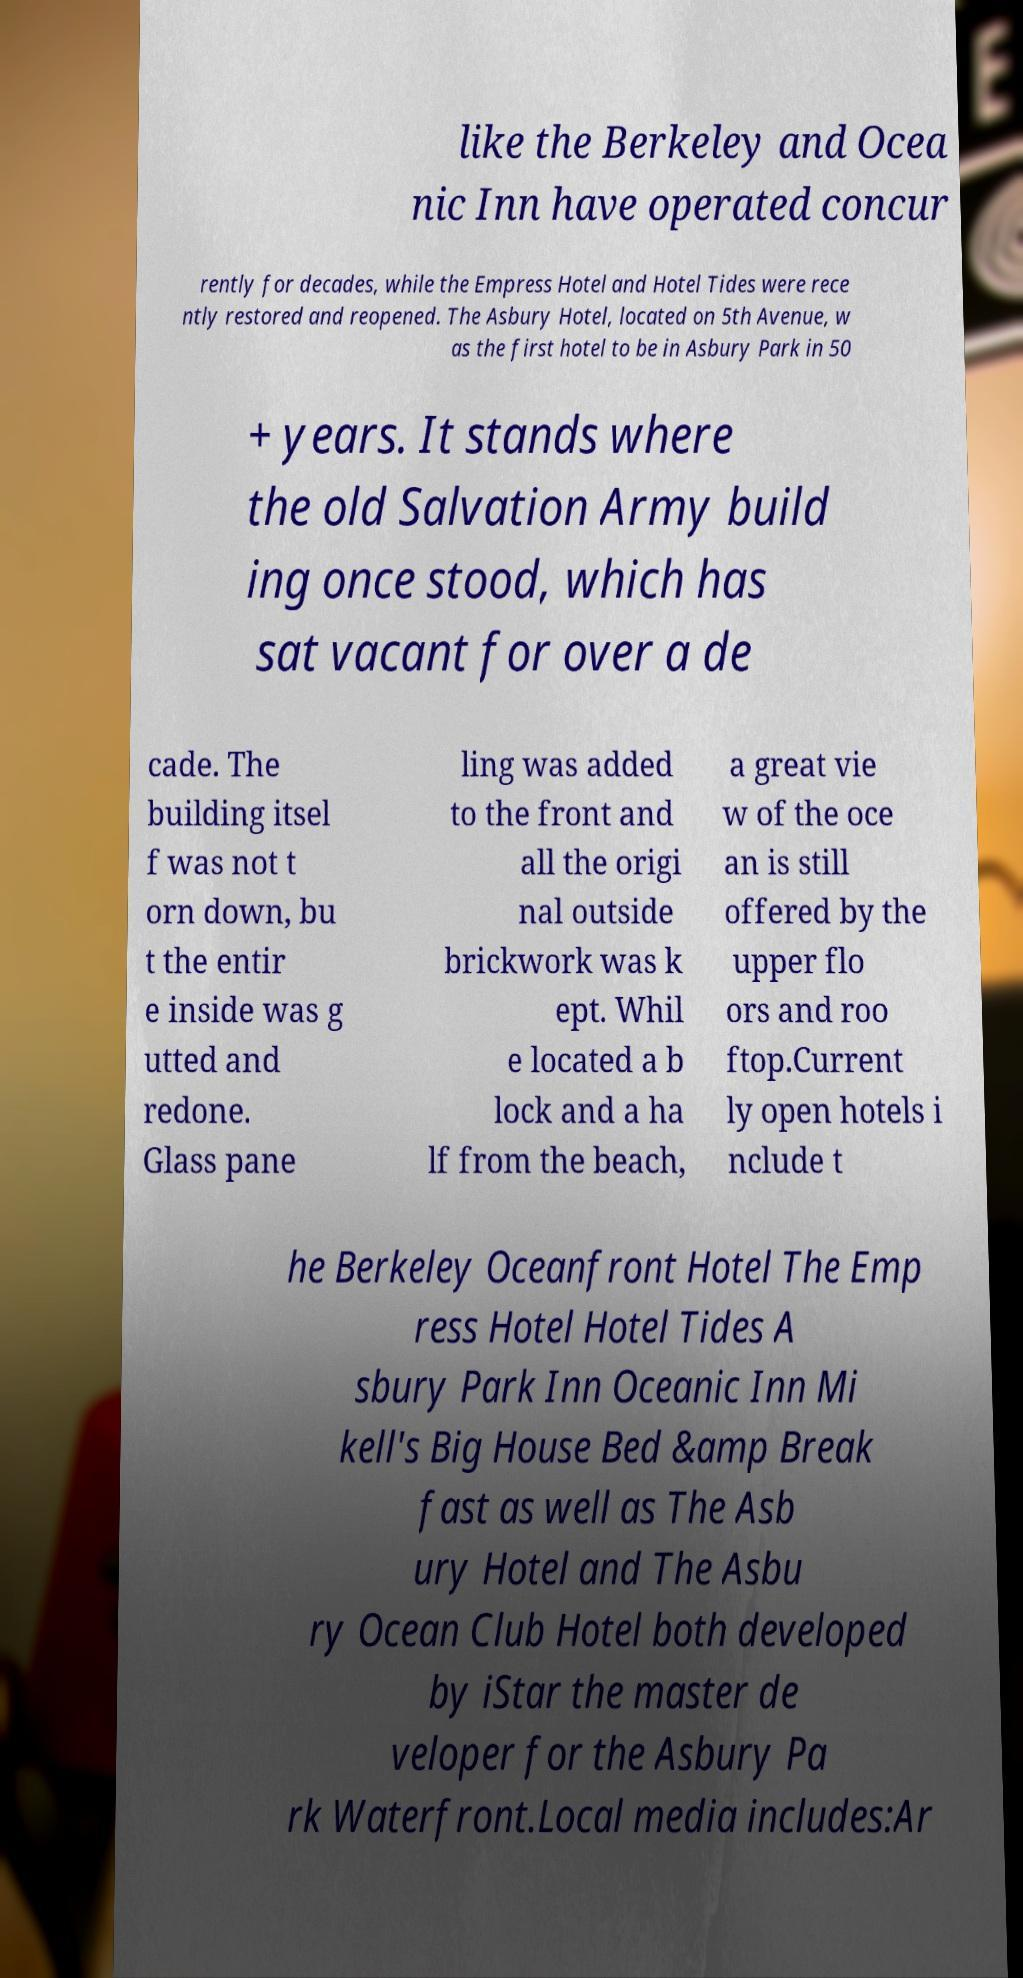Please identify and transcribe the text found in this image. like the Berkeley and Ocea nic Inn have operated concur rently for decades, while the Empress Hotel and Hotel Tides were rece ntly restored and reopened. The Asbury Hotel, located on 5th Avenue, w as the first hotel to be in Asbury Park in 50 + years. It stands where the old Salvation Army build ing once stood, which has sat vacant for over a de cade. The building itsel f was not t orn down, bu t the entir e inside was g utted and redone. Glass pane ling was added to the front and all the origi nal outside brickwork was k ept. Whil e located a b lock and a ha lf from the beach, a great vie w of the oce an is still offered by the upper flo ors and roo ftop.Current ly open hotels i nclude t he Berkeley Oceanfront Hotel The Emp ress Hotel Hotel Tides A sbury Park Inn Oceanic Inn Mi kell's Big House Bed &amp Break fast as well as The Asb ury Hotel and The Asbu ry Ocean Club Hotel both developed by iStar the master de veloper for the Asbury Pa rk Waterfront.Local media includes:Ar 